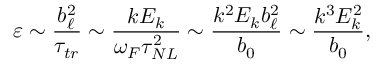Convert formula to latex. <formula><loc_0><loc_0><loc_500><loc_500>\varepsilon \sim \frac { b _ { \ell } ^ { 2 } } { \tau _ { t r } } \sim \frac { k E _ { k } } { \omega _ { F } \tau _ { N L } ^ { 2 } } \sim \frac { k ^ { 2 } E _ { k } b _ { \ell } ^ { 2 } } { b _ { 0 } } \sim \frac { k ^ { 3 } E _ { k } ^ { 2 } } { b _ { 0 } } ,</formula> 